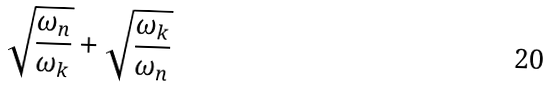<formula> <loc_0><loc_0><loc_500><loc_500>\sqrt { \frac { \omega _ { n } } { \omega _ { k } } } + \sqrt { \frac { \omega _ { k } } { \omega _ { n } } }</formula> 